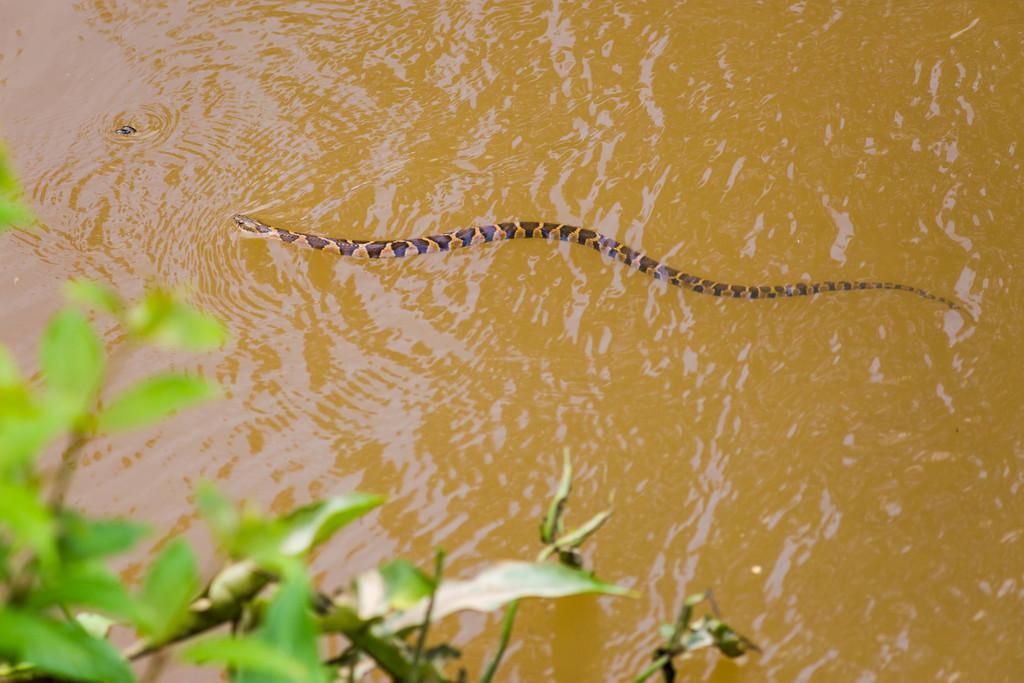Could you give a brief overview of what you see in this image? In this image I can see snake on the water, beside that there is a plant. 